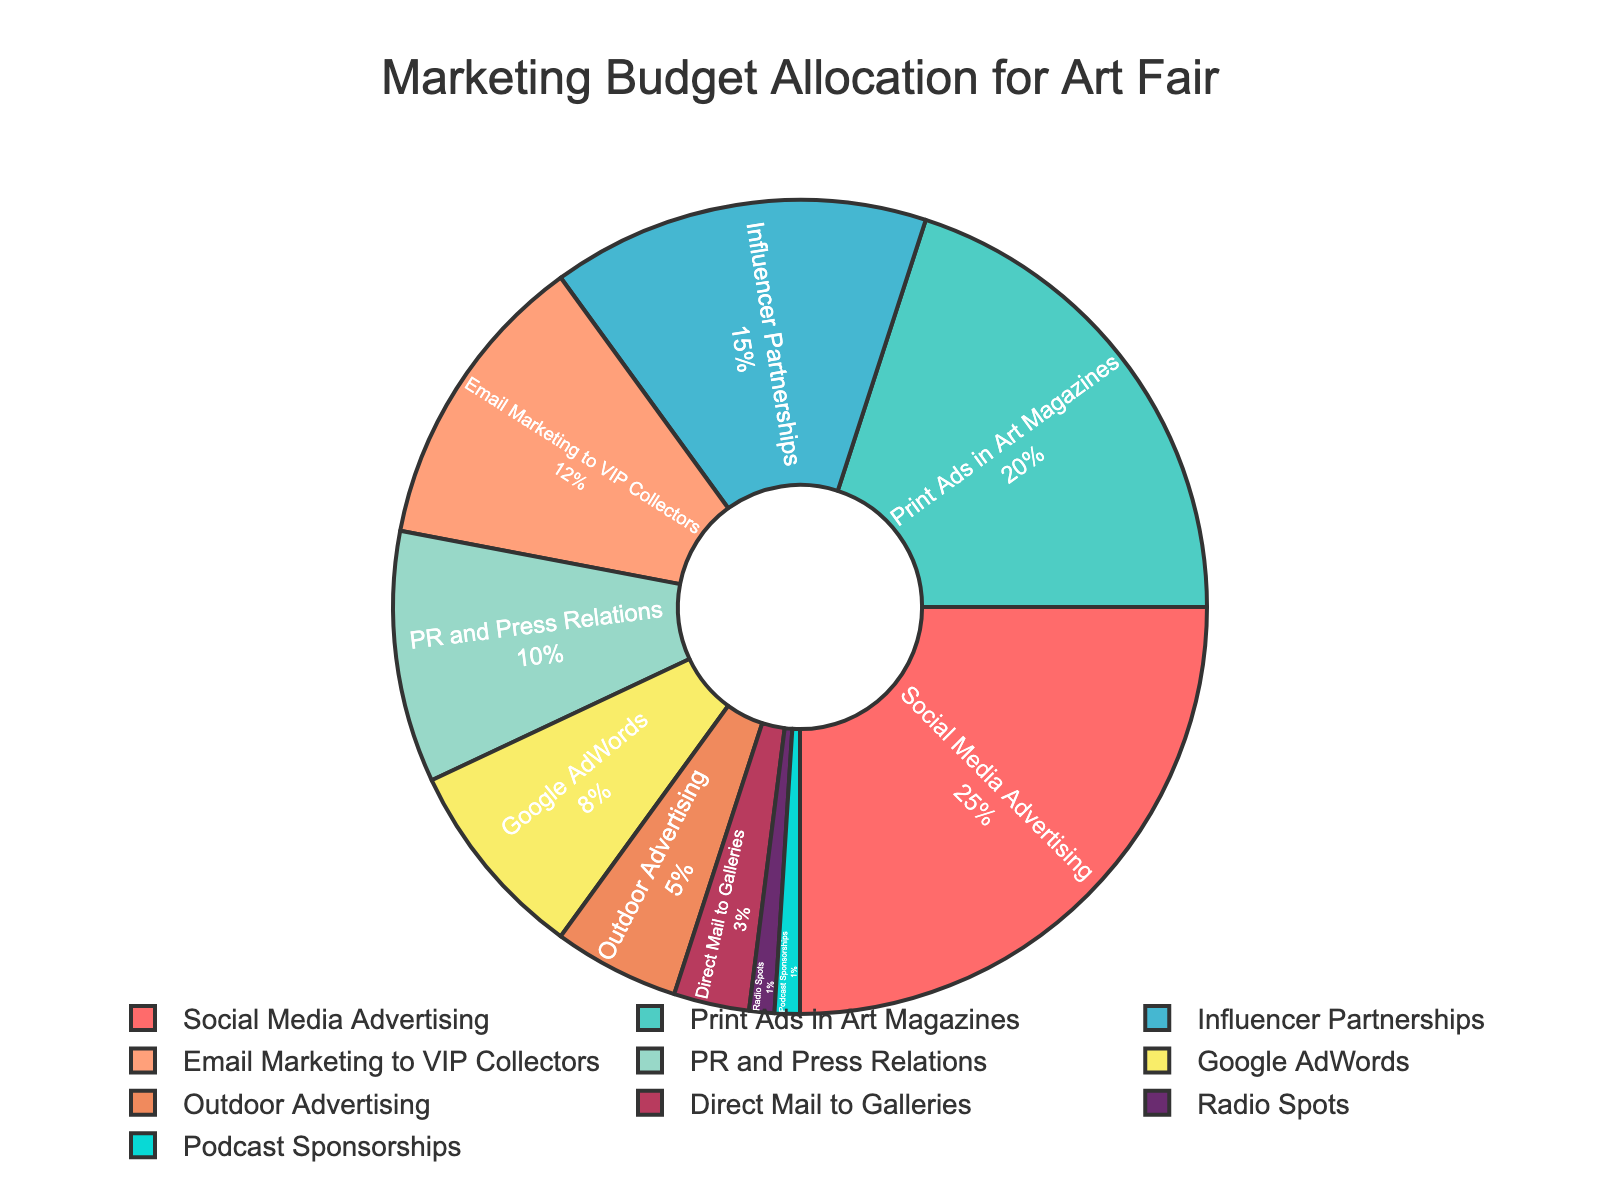What's the total percentage allocated to Social Media Advertising and Print Ads in Art Magazines? Adding the percentages for Social Media Advertising (25%) and Print Ads in Art Magazines (20%) gives us 25 + 20 = 45%.
Answer: 45% Which promotional channel has a higher allocation: Google AdWords or Email Marketing to VIP Collectors? Google AdWords has 8% of the budget, while Email Marketing to VIP Collectors has 12%. Since 12% is greater than 8%, Email Marketing to VIP Collectors has a higher allocation.
Answer: Email Marketing to VIP Collectors What is the percentage difference between Influencer Partnerships and Outdoor Advertising? Influencer Partnerships have 15% of the budget, and Outdoor Advertising has 5%. The difference is 15 - 5 = 10%.
Answer: 10% How many channels have a budget allocation of more than 10%? Social Media Advertising (25%), Print Ads in Art Magazines (20%), Influencer Partnerships (15%), and Email Marketing to VIP Collectors (12%) each have more than 10%. We count four channels.
Answer: 4 Which two channels have the smallest budget allocations, and what are their percentages? Radio Spots and Podcast Sponsorships both have the smallest allocations at 1% each.
Answer: Radio Spots and Podcast Sponsorships, 1% each What is the combined budget allocation for Radio Spots, Podcast Sponsorships, and Direct Mail to Galleries? Adding the percentages for Radio Spots (1%), Podcast Sponsorships (1%), and Direct Mail to Galleries (3%) gives us 1 + 1 + 3 = 5%.
Answer: 5% Which color represents Print Ads in Art Magazines and what is its budget allocation? Print Ads in Art Magazines is represented by the second segment which is green in color, and its budget allocation is 20%.
Answer: Green, 20% Compare the budget allocation for PR and Press Relations and Social Media Advertising. Which one has a larger share and by how much? Social Media Advertising has 25%, whereas PR and Press Relations has 10%. The difference is 25 - 10 = 15%. Social Media Advertising has a larger share by 15%.
Answer: Social Media Advertising by 15% What percentage of the budget is allocated to channels other than the top two highest allocations? The two highest allocations are Social Media Advertising (25%) and Print Ads in Art Magazines (20%), summing to 45%. The total budget is 100%, so 100 - 45 = 55% is allocated to other channels.
Answer: 55% Find the average percentage allocation for Influencer Partnerships, Google AdWords, and Outdoor Advertising. The percentages are Influencer Partnerships (15%), Google AdWords (8%), and Outdoor Advertising (5%). The sum of these percentages is 15 + 8 + 5 = 28%, and the average is 28 / 3 ≈ 9.33%.
Answer: 9.33% 